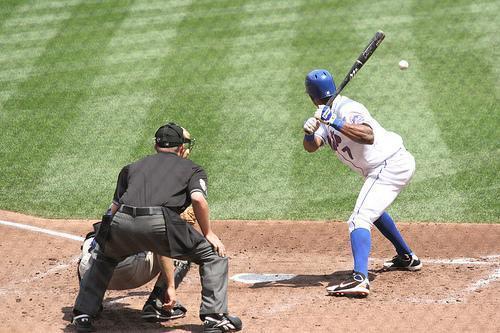How many people are pictured?
Give a very brief answer. 3. 